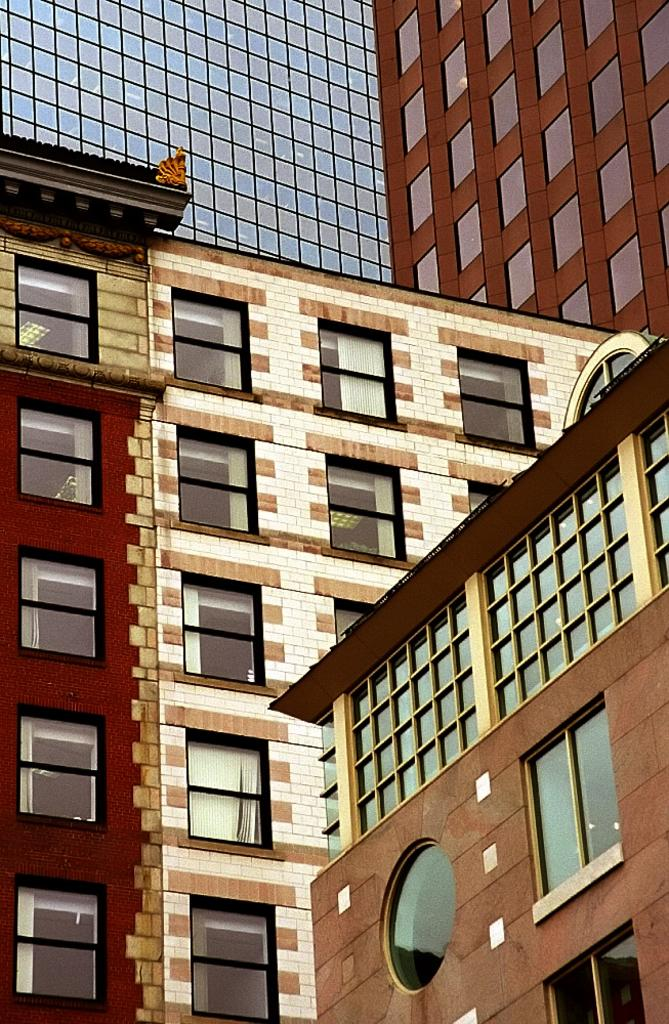What type of structures can be seen in the foreground of the image? There are buildings in the foreground of the image. Can you hear the bat laughing while receiving a reward in the image? There is no bat, laughter, or reward present in the image; it only features buildings in the foreground. 